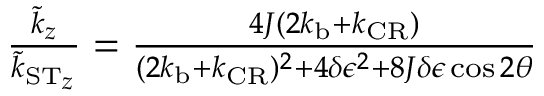<formula> <loc_0><loc_0><loc_500><loc_500>\begin{array} { r } { \frac { \tilde { k } _ { z } } { \tilde { k } _ { { S } { T } _ { z } } } = \frac { 4 J ( 2 k _ { b } + k _ { C R } ) } { ( 2 k _ { b } + k _ { C R } ) ^ { 2 } + 4 \delta \epsilon ^ { 2 } + 8 J \delta \epsilon \cos 2 \theta } } \end{array}</formula> 